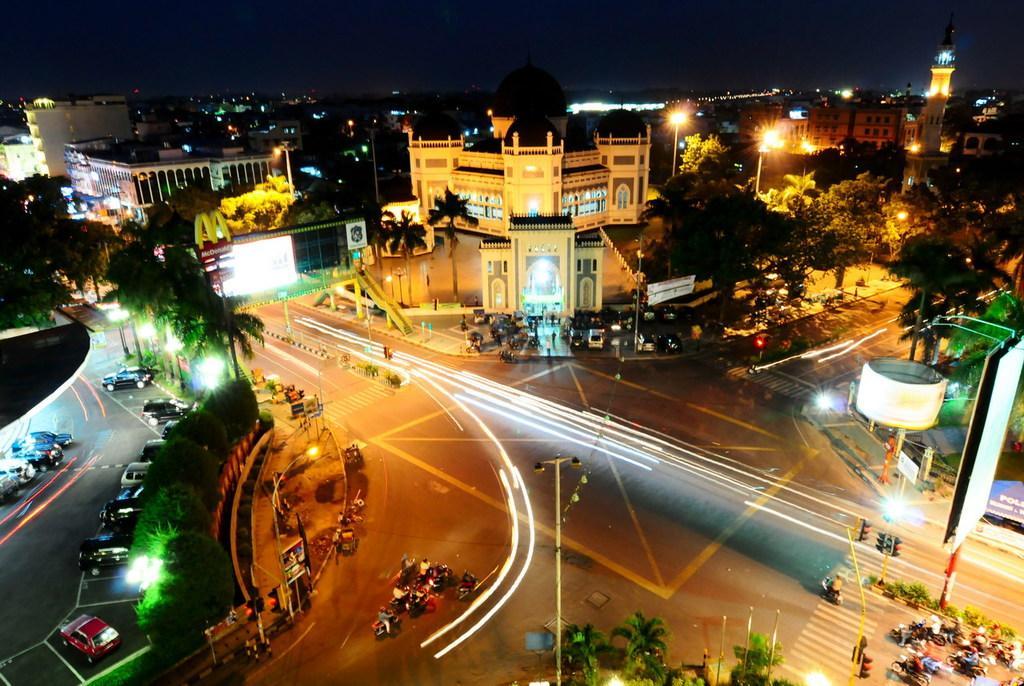Describe this image in one or two sentences. In this image, we can see buildings, towers, lights, poles, vehicles on the road and we can see name boards and signboards and there are traffic cones, traffic lights on the road. 